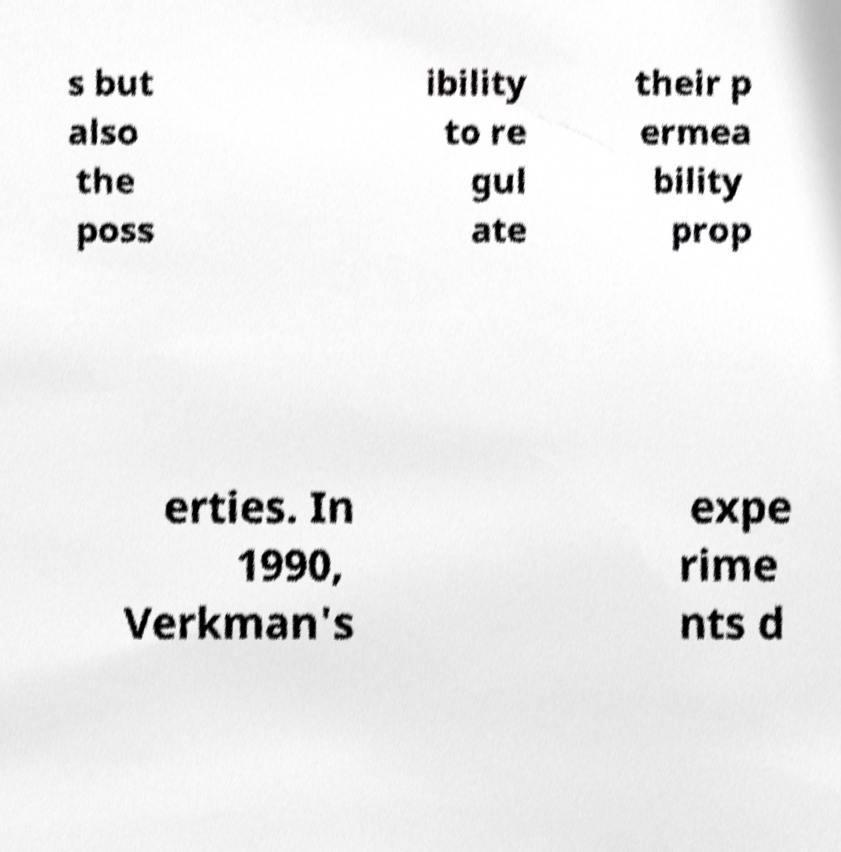Please identify and transcribe the text found in this image. s but also the poss ibility to re gul ate their p ermea bility prop erties. In 1990, Verkman's expe rime nts d 